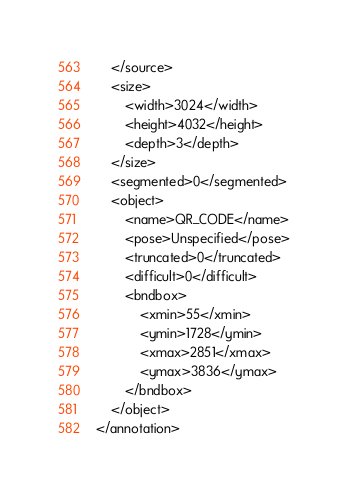<code> <loc_0><loc_0><loc_500><loc_500><_XML_>	</source>
	<size>
		<width>3024</width>
		<height>4032</height>
		<depth>3</depth>
	</size>
	<segmented>0</segmented>
	<object>
		<name>QR_CODE</name>
		<pose>Unspecified</pose>
		<truncated>0</truncated>
		<difficult>0</difficult>
		<bndbox>
			<xmin>55</xmin>
			<ymin>1728</ymin>
			<xmax>2851</xmax>
			<ymax>3836</ymax>
		</bndbox>
	</object>
</annotation>
</code> 